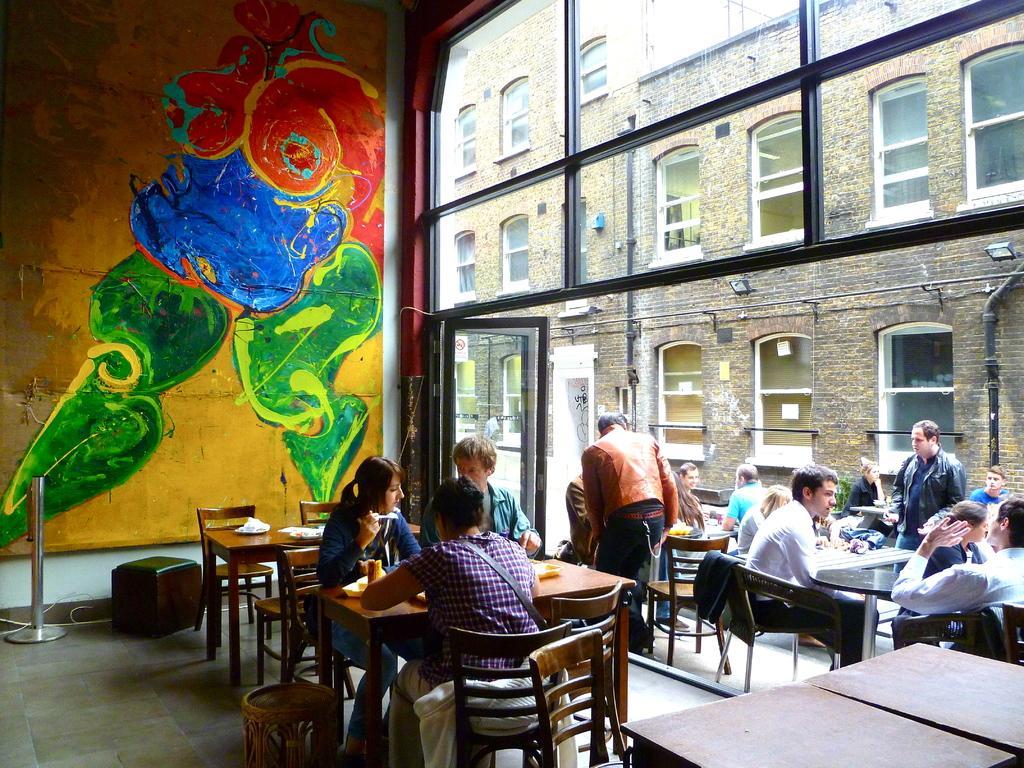Can you describe this image briefly? In this given picture we can observe some people sitting around their respective tables in the chairs. There's a man standing here and some of them are also sitting here. In the background there is a painting on the wall. We can observe a building here. 